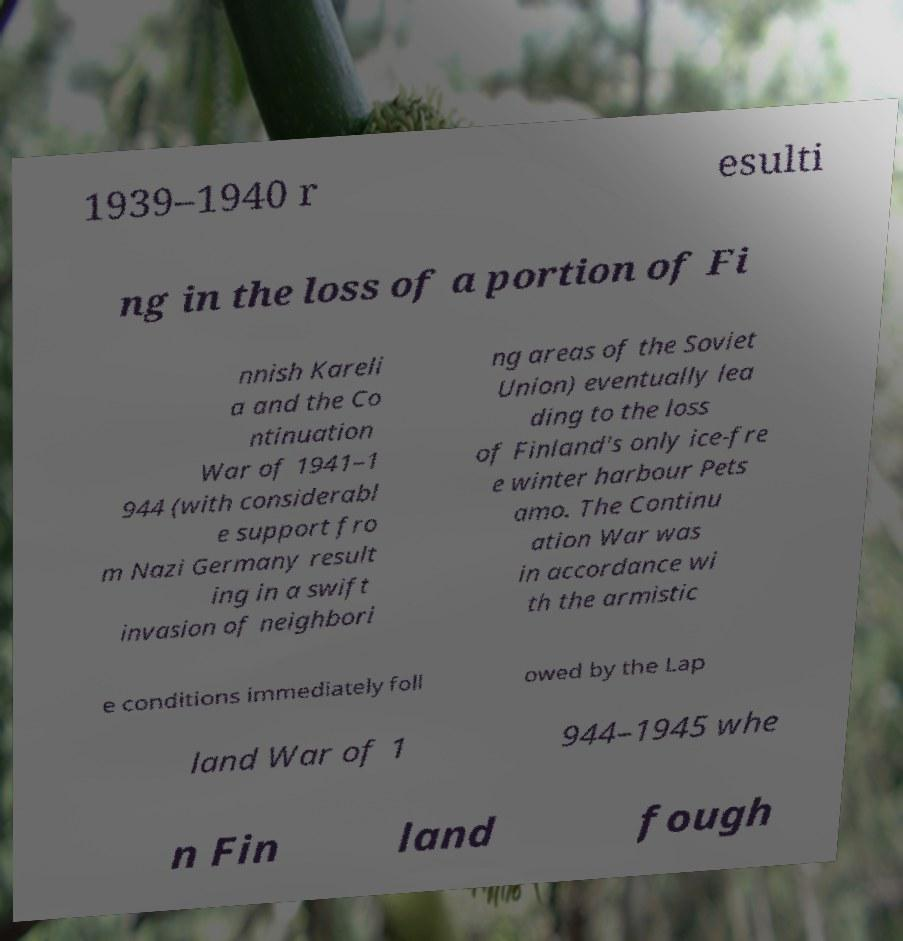Please identify and transcribe the text found in this image. 1939–1940 r esulti ng in the loss of a portion of Fi nnish Kareli a and the Co ntinuation War of 1941–1 944 (with considerabl e support fro m Nazi Germany result ing in a swift invasion of neighbori ng areas of the Soviet Union) eventually lea ding to the loss of Finland's only ice-fre e winter harbour Pets amo. The Continu ation War was in accordance wi th the armistic e conditions immediately foll owed by the Lap land War of 1 944–1945 whe n Fin land fough 